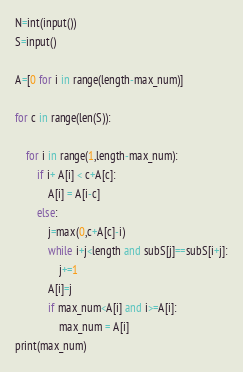Convert code to text. <code><loc_0><loc_0><loc_500><loc_500><_Python_>N=int(input())
S=input()

A=[0 for i in range(length-max_num)]

for c in range(len(S)):

    for i in range(1,length-max_num):
        if i+ A[i] < c+A[c]:
            A[i] = A[i-c]
        else:
            j=max(0,c+A[c]-i)
            while i+j<length and subS[j]==subS[i+j]:
                j+=1
            A[i]=j
            if max_num<A[i] and i>=A[i]:
                max_num = A[i]
print(max_num)</code> 